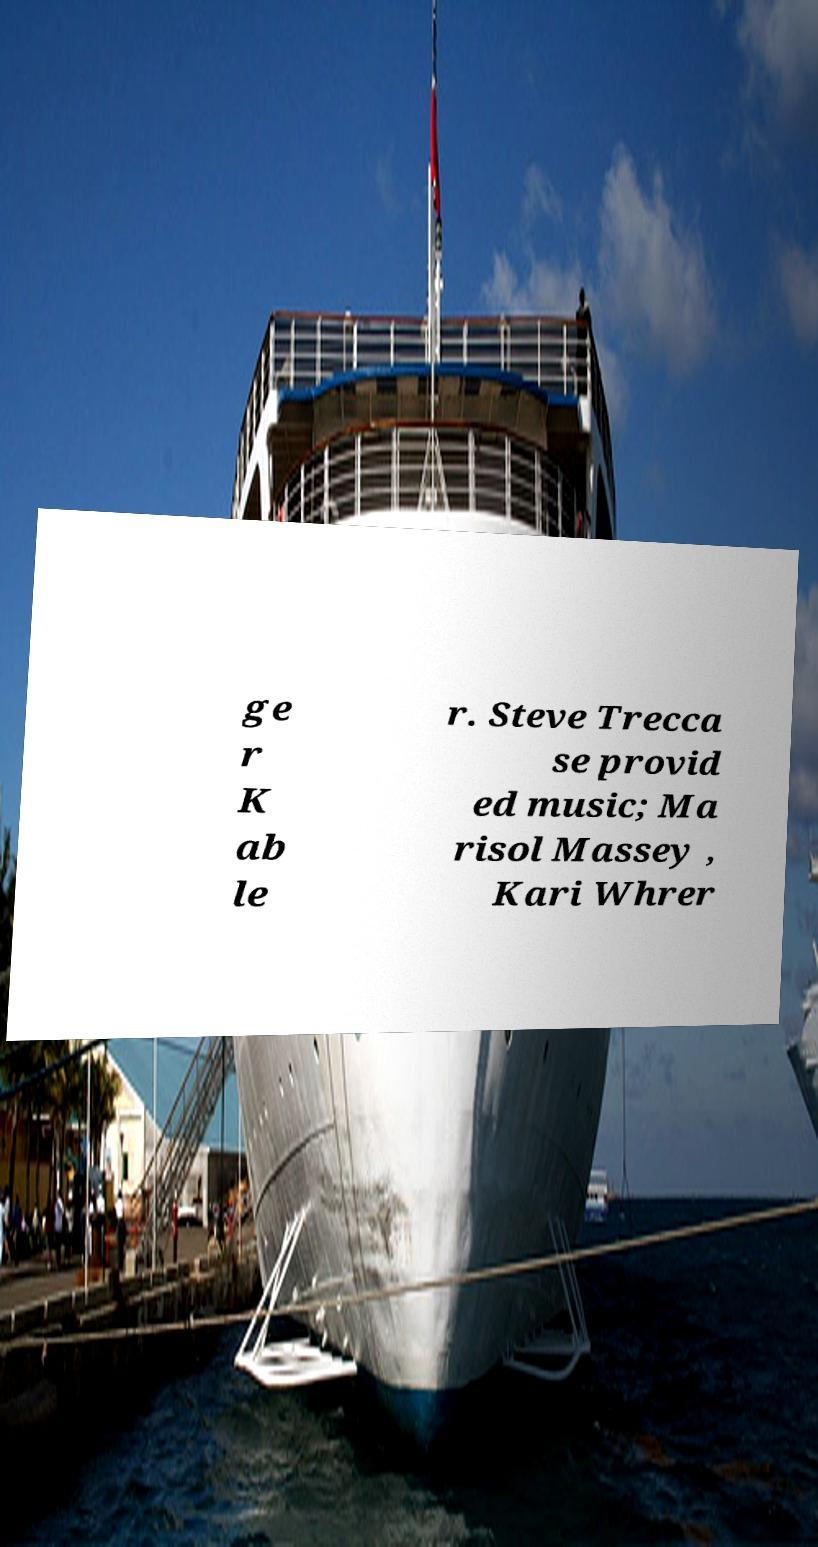Could you extract and type out the text from this image? ge r K ab le r. Steve Trecca se provid ed music; Ma risol Massey , Kari Whrer 